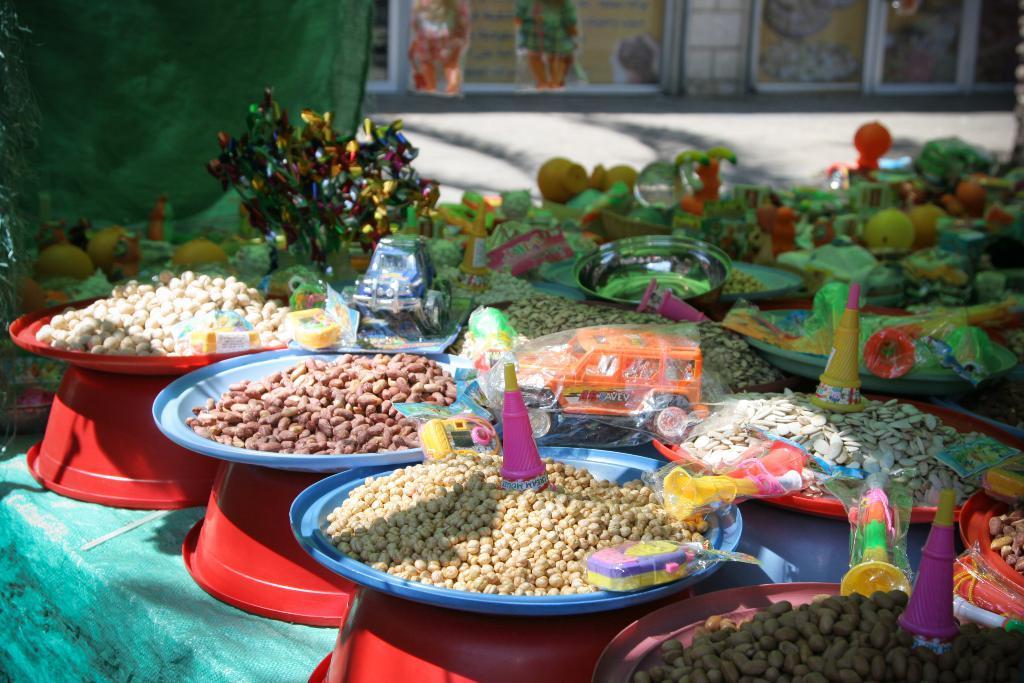Could you give a brief overview of what you see in this image? In this image we can see different types of food items and toys are there. 